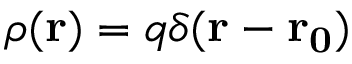Convert formula to latex. <formula><loc_0><loc_0><loc_500><loc_500>\rho ( r ) = q \delta ( r - r _ { 0 } )</formula> 